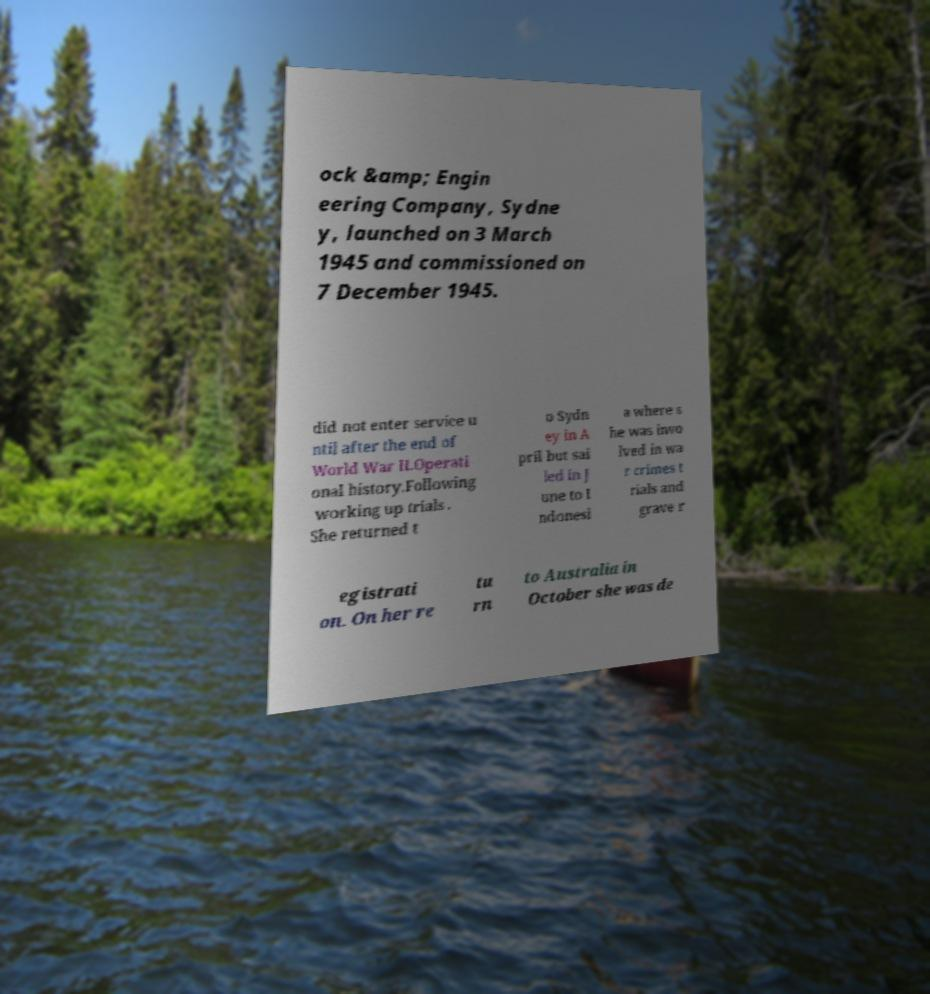Can you accurately transcribe the text from the provided image for me? ock &amp; Engin eering Company, Sydne y, launched on 3 March 1945 and commissioned on 7 December 1945. did not enter service u ntil after the end of World War II.Operati onal history.Following working up trials . She returned t o Sydn ey in A pril but sai led in J une to I ndonesi a where s he was invo lved in wa r crimes t rials and grave r egistrati on. On her re tu rn to Australia in October she was de 